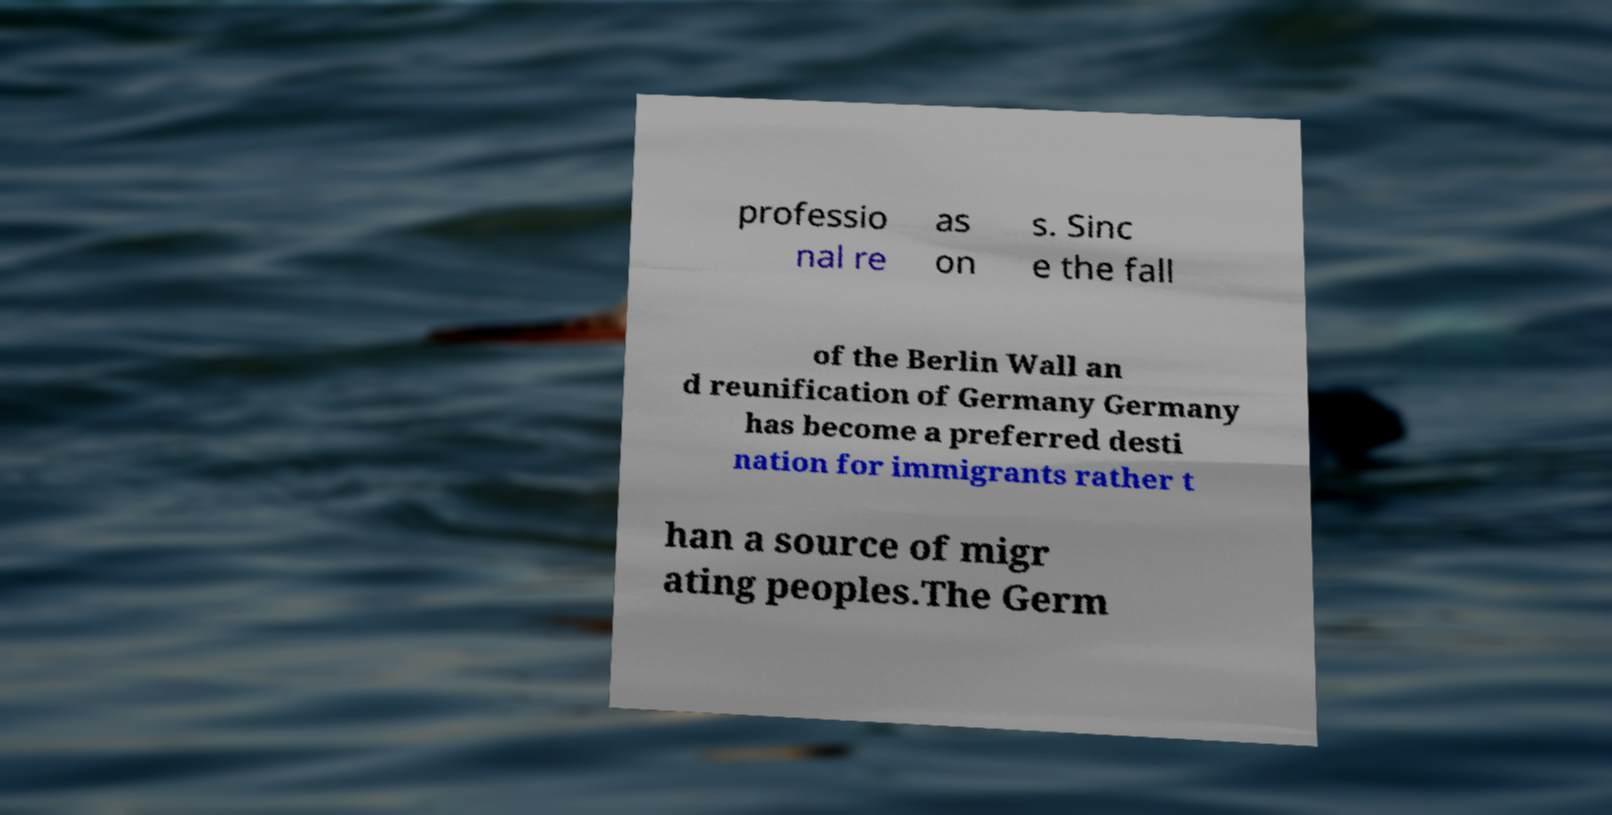Could you extract and type out the text from this image? professio nal re as on s. Sinc e the fall of the Berlin Wall an d reunification of Germany Germany has become a preferred desti nation for immigrants rather t han a source of migr ating peoples.The Germ 